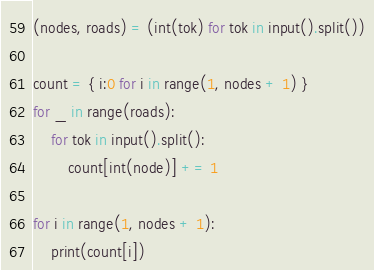<code> <loc_0><loc_0><loc_500><loc_500><_Python_>(nodes, roads) = (int(tok) for tok in input().split())

count = { i:0 for i in range(1, nodes + 1) }
for _ in range(roads):
	for tok in input().split():
		count[int(node)] += 1
          
for i in range(1, nodes + 1):
	print(count[i])</code> 